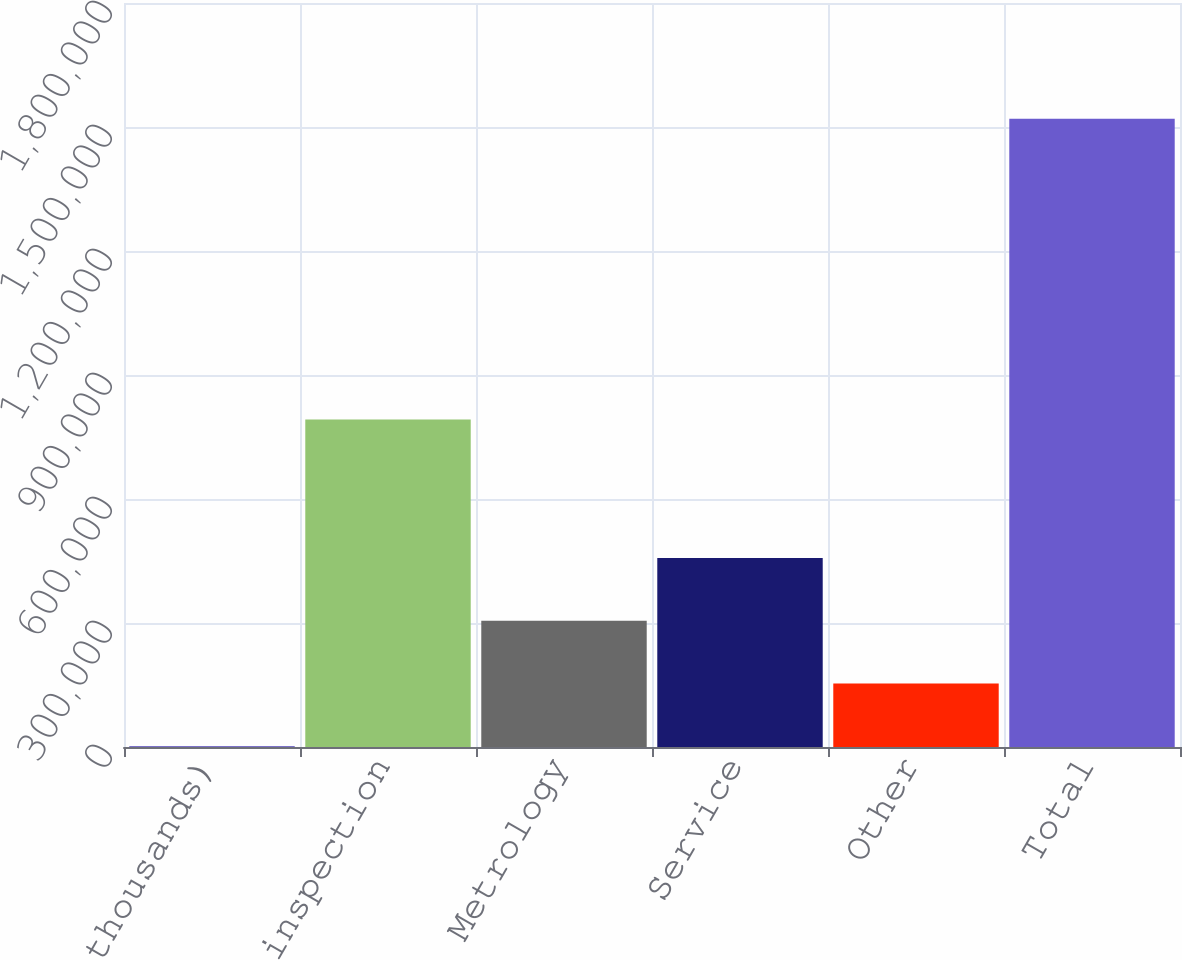Convert chart. <chart><loc_0><loc_0><loc_500><loc_500><bar_chart><fcel>(In thousands)<fcel>Defect inspection<fcel>Metrology<fcel>Service<fcel>Other<fcel>Total<nl><fcel>2009<fcel>792160<fcel>305650<fcel>457471<fcel>153830<fcel>1.52022e+06<nl></chart> 